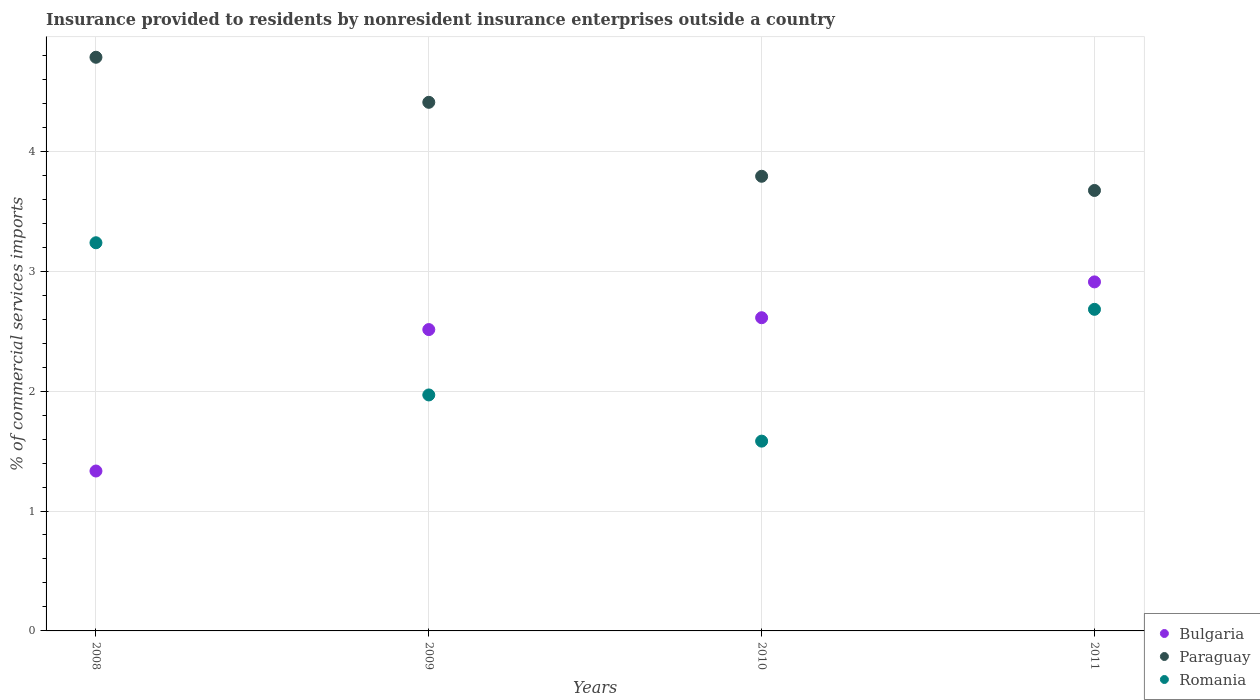How many different coloured dotlines are there?
Keep it short and to the point. 3. What is the Insurance provided to residents in Paraguay in 2009?
Ensure brevity in your answer.  4.41. Across all years, what is the maximum Insurance provided to residents in Paraguay?
Your answer should be very brief. 4.78. Across all years, what is the minimum Insurance provided to residents in Romania?
Your answer should be very brief. 1.58. In which year was the Insurance provided to residents in Bulgaria minimum?
Your answer should be compact. 2008. What is the total Insurance provided to residents in Bulgaria in the graph?
Offer a terse response. 9.37. What is the difference between the Insurance provided to residents in Bulgaria in 2008 and that in 2010?
Make the answer very short. -1.28. What is the difference between the Insurance provided to residents in Paraguay in 2008 and the Insurance provided to residents in Romania in 2010?
Offer a terse response. 3.2. What is the average Insurance provided to residents in Paraguay per year?
Make the answer very short. 4.16. In the year 2010, what is the difference between the Insurance provided to residents in Romania and Insurance provided to residents in Paraguay?
Your response must be concise. -2.21. In how many years, is the Insurance provided to residents in Romania greater than 2.4 %?
Your response must be concise. 2. What is the ratio of the Insurance provided to residents in Bulgaria in 2008 to that in 2010?
Your response must be concise. 0.51. What is the difference between the highest and the second highest Insurance provided to residents in Romania?
Offer a very short reply. 0.56. What is the difference between the highest and the lowest Insurance provided to residents in Romania?
Your answer should be very brief. 1.65. In how many years, is the Insurance provided to residents in Romania greater than the average Insurance provided to residents in Romania taken over all years?
Your answer should be compact. 2. Is the sum of the Insurance provided to residents in Bulgaria in 2008 and 2010 greater than the maximum Insurance provided to residents in Romania across all years?
Ensure brevity in your answer.  Yes. Does the Insurance provided to residents in Bulgaria monotonically increase over the years?
Offer a very short reply. Yes. How many dotlines are there?
Provide a succinct answer. 3. What is the difference between two consecutive major ticks on the Y-axis?
Ensure brevity in your answer.  1. How many legend labels are there?
Your answer should be compact. 3. How are the legend labels stacked?
Provide a succinct answer. Vertical. What is the title of the graph?
Keep it short and to the point. Insurance provided to residents by nonresident insurance enterprises outside a country. What is the label or title of the X-axis?
Offer a terse response. Years. What is the label or title of the Y-axis?
Offer a very short reply. % of commercial services imports. What is the % of commercial services imports of Bulgaria in 2008?
Keep it short and to the point. 1.33. What is the % of commercial services imports in Paraguay in 2008?
Your answer should be compact. 4.78. What is the % of commercial services imports in Romania in 2008?
Your response must be concise. 3.24. What is the % of commercial services imports of Bulgaria in 2009?
Provide a short and direct response. 2.51. What is the % of commercial services imports of Paraguay in 2009?
Your answer should be compact. 4.41. What is the % of commercial services imports in Romania in 2009?
Ensure brevity in your answer.  1.97. What is the % of commercial services imports in Bulgaria in 2010?
Your response must be concise. 2.61. What is the % of commercial services imports in Paraguay in 2010?
Give a very brief answer. 3.79. What is the % of commercial services imports of Romania in 2010?
Offer a terse response. 1.58. What is the % of commercial services imports of Bulgaria in 2011?
Your answer should be very brief. 2.91. What is the % of commercial services imports in Paraguay in 2011?
Offer a terse response. 3.67. What is the % of commercial services imports of Romania in 2011?
Keep it short and to the point. 2.68. Across all years, what is the maximum % of commercial services imports in Bulgaria?
Offer a very short reply. 2.91. Across all years, what is the maximum % of commercial services imports in Paraguay?
Provide a short and direct response. 4.78. Across all years, what is the maximum % of commercial services imports in Romania?
Make the answer very short. 3.24. Across all years, what is the minimum % of commercial services imports of Bulgaria?
Provide a succinct answer. 1.33. Across all years, what is the minimum % of commercial services imports of Paraguay?
Your answer should be very brief. 3.67. Across all years, what is the minimum % of commercial services imports in Romania?
Your answer should be very brief. 1.58. What is the total % of commercial services imports in Bulgaria in the graph?
Keep it short and to the point. 9.37. What is the total % of commercial services imports in Paraguay in the graph?
Offer a very short reply. 16.66. What is the total % of commercial services imports in Romania in the graph?
Give a very brief answer. 9.47. What is the difference between the % of commercial services imports of Bulgaria in 2008 and that in 2009?
Make the answer very short. -1.18. What is the difference between the % of commercial services imports in Paraguay in 2008 and that in 2009?
Provide a succinct answer. 0.38. What is the difference between the % of commercial services imports in Romania in 2008 and that in 2009?
Your answer should be compact. 1.27. What is the difference between the % of commercial services imports of Bulgaria in 2008 and that in 2010?
Give a very brief answer. -1.28. What is the difference between the % of commercial services imports of Paraguay in 2008 and that in 2010?
Your answer should be compact. 0.99. What is the difference between the % of commercial services imports of Romania in 2008 and that in 2010?
Your answer should be very brief. 1.65. What is the difference between the % of commercial services imports in Bulgaria in 2008 and that in 2011?
Keep it short and to the point. -1.58. What is the difference between the % of commercial services imports in Paraguay in 2008 and that in 2011?
Offer a very short reply. 1.11. What is the difference between the % of commercial services imports in Romania in 2008 and that in 2011?
Provide a succinct answer. 0.56. What is the difference between the % of commercial services imports in Bulgaria in 2009 and that in 2010?
Your answer should be very brief. -0.1. What is the difference between the % of commercial services imports in Paraguay in 2009 and that in 2010?
Ensure brevity in your answer.  0.62. What is the difference between the % of commercial services imports in Romania in 2009 and that in 2010?
Offer a terse response. 0.39. What is the difference between the % of commercial services imports in Bulgaria in 2009 and that in 2011?
Provide a succinct answer. -0.4. What is the difference between the % of commercial services imports in Paraguay in 2009 and that in 2011?
Keep it short and to the point. 0.73. What is the difference between the % of commercial services imports in Romania in 2009 and that in 2011?
Make the answer very short. -0.71. What is the difference between the % of commercial services imports of Bulgaria in 2010 and that in 2011?
Give a very brief answer. -0.3. What is the difference between the % of commercial services imports of Paraguay in 2010 and that in 2011?
Ensure brevity in your answer.  0.12. What is the difference between the % of commercial services imports of Romania in 2010 and that in 2011?
Provide a short and direct response. -1.1. What is the difference between the % of commercial services imports in Bulgaria in 2008 and the % of commercial services imports in Paraguay in 2009?
Provide a short and direct response. -3.07. What is the difference between the % of commercial services imports in Bulgaria in 2008 and the % of commercial services imports in Romania in 2009?
Make the answer very short. -0.63. What is the difference between the % of commercial services imports of Paraguay in 2008 and the % of commercial services imports of Romania in 2009?
Your answer should be very brief. 2.82. What is the difference between the % of commercial services imports of Bulgaria in 2008 and the % of commercial services imports of Paraguay in 2010?
Give a very brief answer. -2.46. What is the difference between the % of commercial services imports in Bulgaria in 2008 and the % of commercial services imports in Romania in 2010?
Keep it short and to the point. -0.25. What is the difference between the % of commercial services imports in Paraguay in 2008 and the % of commercial services imports in Romania in 2010?
Provide a succinct answer. 3.2. What is the difference between the % of commercial services imports of Bulgaria in 2008 and the % of commercial services imports of Paraguay in 2011?
Provide a succinct answer. -2.34. What is the difference between the % of commercial services imports in Bulgaria in 2008 and the % of commercial services imports in Romania in 2011?
Offer a terse response. -1.35. What is the difference between the % of commercial services imports in Paraguay in 2008 and the % of commercial services imports in Romania in 2011?
Offer a very short reply. 2.1. What is the difference between the % of commercial services imports of Bulgaria in 2009 and the % of commercial services imports of Paraguay in 2010?
Offer a very short reply. -1.28. What is the difference between the % of commercial services imports in Bulgaria in 2009 and the % of commercial services imports in Romania in 2010?
Your answer should be compact. 0.93. What is the difference between the % of commercial services imports of Paraguay in 2009 and the % of commercial services imports of Romania in 2010?
Your answer should be very brief. 2.83. What is the difference between the % of commercial services imports in Bulgaria in 2009 and the % of commercial services imports in Paraguay in 2011?
Offer a very short reply. -1.16. What is the difference between the % of commercial services imports of Bulgaria in 2009 and the % of commercial services imports of Romania in 2011?
Your response must be concise. -0.17. What is the difference between the % of commercial services imports in Paraguay in 2009 and the % of commercial services imports in Romania in 2011?
Offer a terse response. 1.73. What is the difference between the % of commercial services imports of Bulgaria in 2010 and the % of commercial services imports of Paraguay in 2011?
Keep it short and to the point. -1.06. What is the difference between the % of commercial services imports in Bulgaria in 2010 and the % of commercial services imports in Romania in 2011?
Your answer should be compact. -0.07. What is the difference between the % of commercial services imports of Paraguay in 2010 and the % of commercial services imports of Romania in 2011?
Your answer should be compact. 1.11. What is the average % of commercial services imports of Bulgaria per year?
Give a very brief answer. 2.34. What is the average % of commercial services imports in Paraguay per year?
Offer a very short reply. 4.16. What is the average % of commercial services imports in Romania per year?
Your response must be concise. 2.37. In the year 2008, what is the difference between the % of commercial services imports of Bulgaria and % of commercial services imports of Paraguay?
Ensure brevity in your answer.  -3.45. In the year 2008, what is the difference between the % of commercial services imports of Bulgaria and % of commercial services imports of Romania?
Make the answer very short. -1.9. In the year 2008, what is the difference between the % of commercial services imports in Paraguay and % of commercial services imports in Romania?
Provide a short and direct response. 1.55. In the year 2009, what is the difference between the % of commercial services imports in Bulgaria and % of commercial services imports in Paraguay?
Offer a terse response. -1.9. In the year 2009, what is the difference between the % of commercial services imports in Bulgaria and % of commercial services imports in Romania?
Give a very brief answer. 0.55. In the year 2009, what is the difference between the % of commercial services imports of Paraguay and % of commercial services imports of Romania?
Make the answer very short. 2.44. In the year 2010, what is the difference between the % of commercial services imports in Bulgaria and % of commercial services imports in Paraguay?
Ensure brevity in your answer.  -1.18. In the year 2010, what is the difference between the % of commercial services imports of Bulgaria and % of commercial services imports of Romania?
Your answer should be very brief. 1.03. In the year 2010, what is the difference between the % of commercial services imports in Paraguay and % of commercial services imports in Romania?
Offer a terse response. 2.21. In the year 2011, what is the difference between the % of commercial services imports of Bulgaria and % of commercial services imports of Paraguay?
Make the answer very short. -0.76. In the year 2011, what is the difference between the % of commercial services imports of Bulgaria and % of commercial services imports of Romania?
Make the answer very short. 0.23. What is the ratio of the % of commercial services imports in Bulgaria in 2008 to that in 2009?
Ensure brevity in your answer.  0.53. What is the ratio of the % of commercial services imports in Paraguay in 2008 to that in 2009?
Your answer should be compact. 1.09. What is the ratio of the % of commercial services imports in Romania in 2008 to that in 2009?
Keep it short and to the point. 1.64. What is the ratio of the % of commercial services imports of Bulgaria in 2008 to that in 2010?
Keep it short and to the point. 0.51. What is the ratio of the % of commercial services imports in Paraguay in 2008 to that in 2010?
Your answer should be very brief. 1.26. What is the ratio of the % of commercial services imports in Romania in 2008 to that in 2010?
Ensure brevity in your answer.  2.05. What is the ratio of the % of commercial services imports of Bulgaria in 2008 to that in 2011?
Give a very brief answer. 0.46. What is the ratio of the % of commercial services imports in Paraguay in 2008 to that in 2011?
Your response must be concise. 1.3. What is the ratio of the % of commercial services imports of Romania in 2008 to that in 2011?
Give a very brief answer. 1.21. What is the ratio of the % of commercial services imports in Bulgaria in 2009 to that in 2010?
Provide a succinct answer. 0.96. What is the ratio of the % of commercial services imports in Paraguay in 2009 to that in 2010?
Offer a very short reply. 1.16. What is the ratio of the % of commercial services imports in Romania in 2009 to that in 2010?
Ensure brevity in your answer.  1.24. What is the ratio of the % of commercial services imports of Bulgaria in 2009 to that in 2011?
Provide a succinct answer. 0.86. What is the ratio of the % of commercial services imports of Paraguay in 2009 to that in 2011?
Ensure brevity in your answer.  1.2. What is the ratio of the % of commercial services imports of Romania in 2009 to that in 2011?
Provide a succinct answer. 0.73. What is the ratio of the % of commercial services imports in Bulgaria in 2010 to that in 2011?
Your answer should be very brief. 0.9. What is the ratio of the % of commercial services imports of Paraguay in 2010 to that in 2011?
Give a very brief answer. 1.03. What is the ratio of the % of commercial services imports in Romania in 2010 to that in 2011?
Offer a very short reply. 0.59. What is the difference between the highest and the second highest % of commercial services imports in Bulgaria?
Offer a terse response. 0.3. What is the difference between the highest and the second highest % of commercial services imports of Paraguay?
Your answer should be compact. 0.38. What is the difference between the highest and the second highest % of commercial services imports in Romania?
Give a very brief answer. 0.56. What is the difference between the highest and the lowest % of commercial services imports of Bulgaria?
Provide a short and direct response. 1.58. What is the difference between the highest and the lowest % of commercial services imports of Paraguay?
Your answer should be very brief. 1.11. What is the difference between the highest and the lowest % of commercial services imports in Romania?
Your response must be concise. 1.65. 